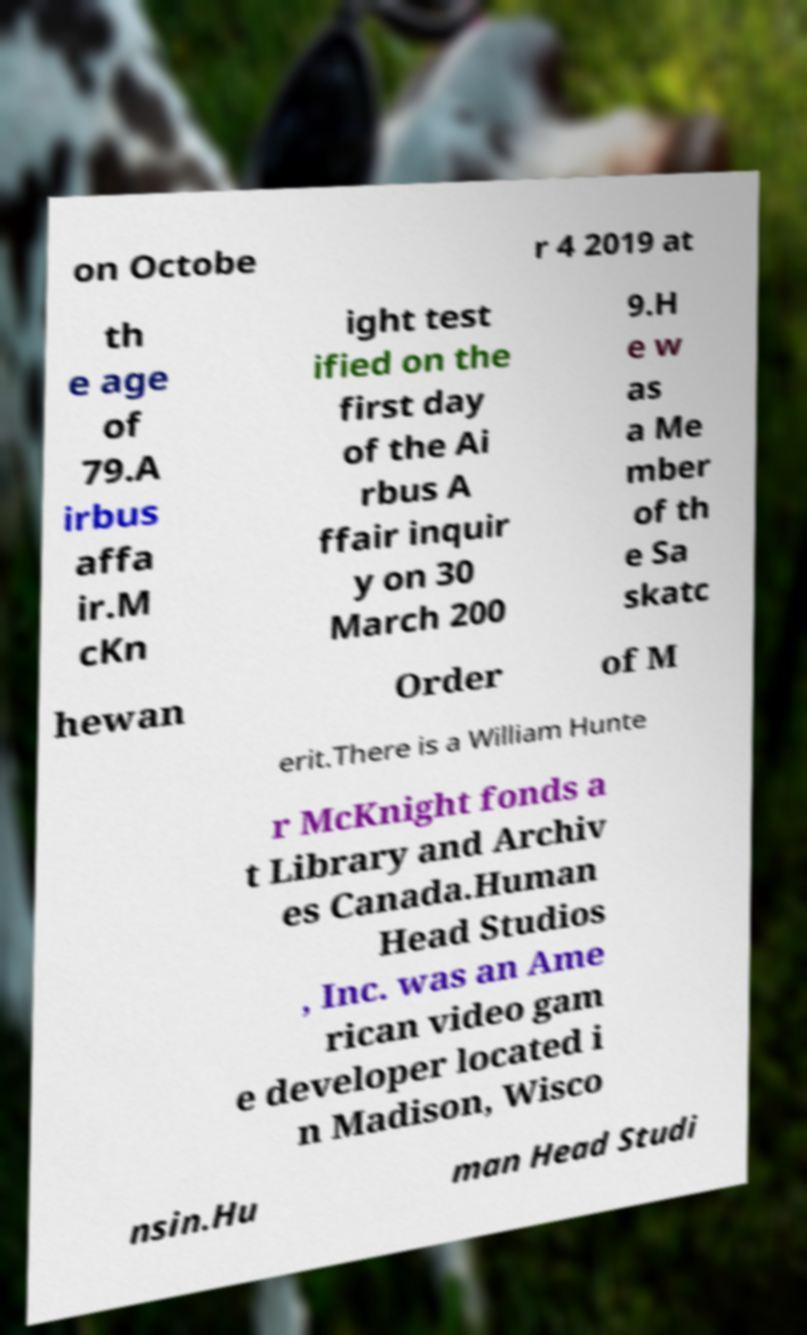For documentation purposes, I need the text within this image transcribed. Could you provide that? on Octobe r 4 2019 at th e age of 79.A irbus affa ir.M cKn ight test ified on the first day of the Ai rbus A ffair inquir y on 30 March 200 9.H e w as a Me mber of th e Sa skatc hewan Order of M erit.There is a William Hunte r McKnight fonds a t Library and Archiv es Canada.Human Head Studios , Inc. was an Ame rican video gam e developer located i n Madison, Wisco nsin.Hu man Head Studi 